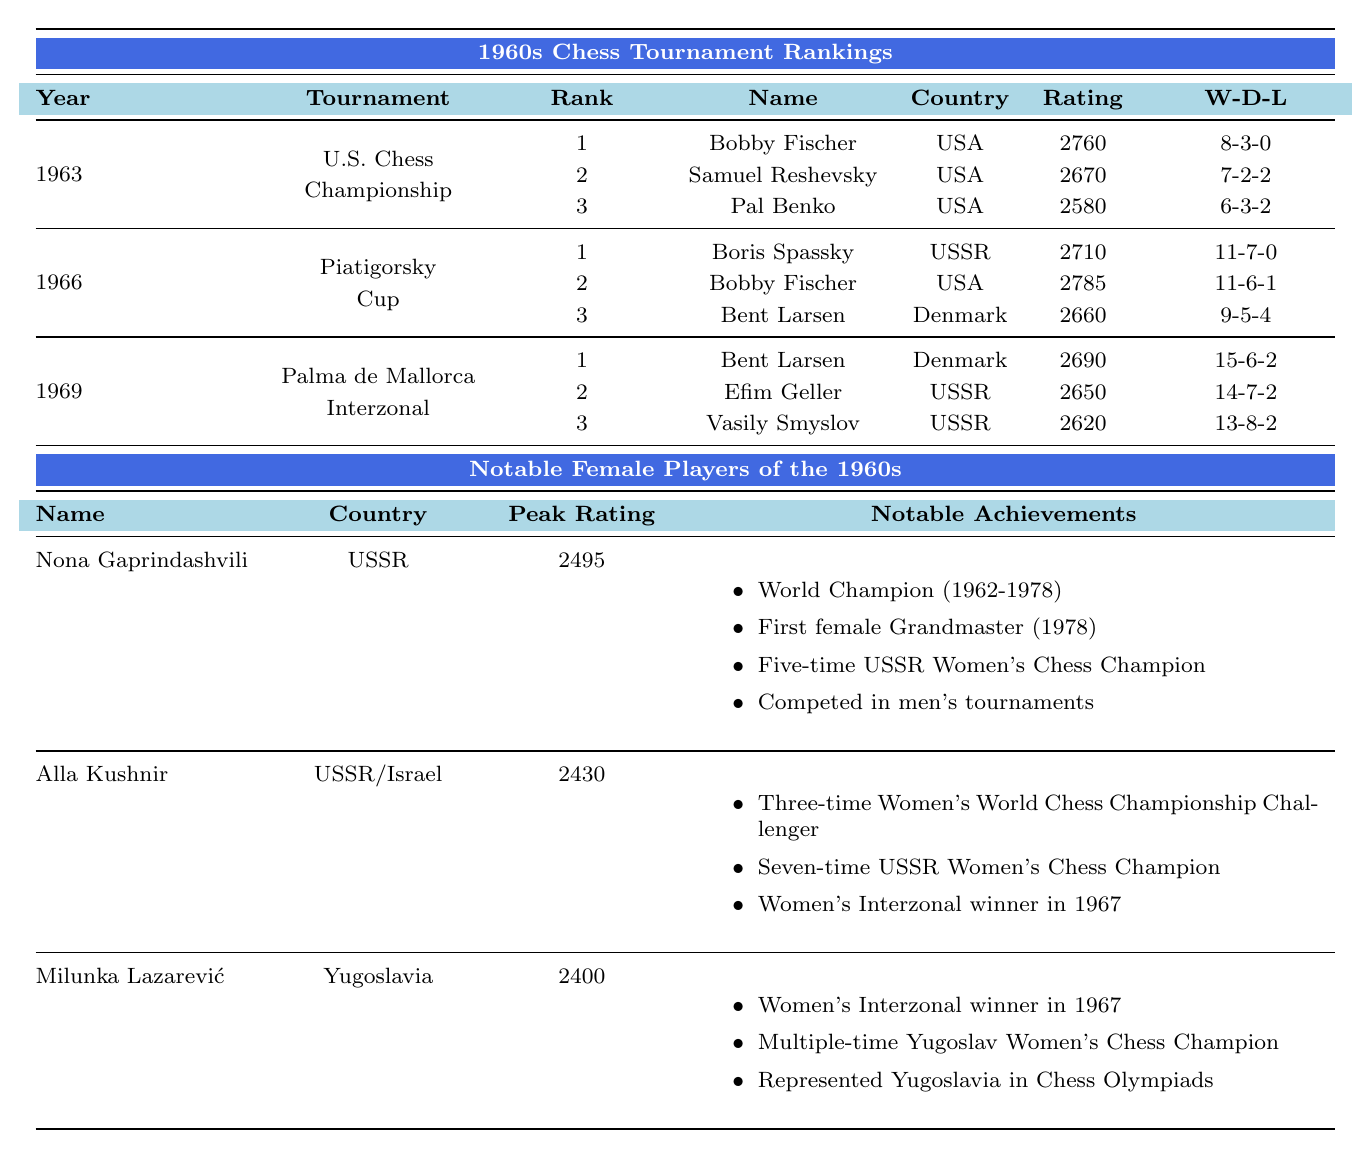What year did Bobby Fischer rank first in the U.S. Chess Championship? Bobby Fischer ranked first in the U.S. Chess Championship in the year 1963, as indicated in the table.
Answer: 1963 Which country did Boris Spassky represent in the Piatigorsky Cup? Boris Spassky represented the USSR in the Piatigorsky Cup, as shown in the tournament rankings.
Answer: USSR What was the highest rating achieved by any player in the Piatigorsky Cup? The highest rating in the Piatigorsky Cup was 2785, achieved by Bobby Fischer. This is indicated in the ratings column.
Answer: 2785 How many games did Bent Larsen play in the Palma de Mallorca Interzonal? Bent Larsen played 23 games in the Palma de Mallorca Interzonal, which is listed in the Games Played column for that tournament.
Answer: 23 Which player had the most wins in the U.S. Chess Championship of 1963? Bobby Fischer had the most wins in the U.S. Chess Championship of 1963 with 8 wins, as noted in the Wins column.
Answer: Bobby Fischer Did Nona Gaprindashvili hold the title of World Champion in the 1960s? Yes, Nona Gaprindashvili was a World Champion from 1962 to 1978, as stated in the table.
Answer: Yes What is the average rating of the top three players in the 1963 U.S. Chess Championship? The ratings of the top three players are 2760, 2670, and 2580. Summing these values gives 8010; dividing by 3 yields an average rating of 2670.
Answer: 2670 How many losses did Bobby Fischer have in the Piatigorsky Cup? Bobby Fischer had 1 loss in the Piatigorsky Cup, as indicated in the Losses column.
Answer: 1 Which player in the Palma de Mallorca Interzonal had the highest number of draws? Vasily Smyslov had the highest number of draws in the Palma de Mallorca Interzonal with 8 draws, as per the Draws column.
Answer: Vasily Smyslov What was the peak rating of Alla Kushnir? Alla Kushnir's peak rating was 2430, as shown in the table under Peak Rating.
Answer: 2430 Which player had a better win-loss ratio: Bent Larsen in 1969 or Bobby Fischer in 1966? Bent Larsen had 15 wins and 2 losses giving a ratio of 15:2, while Bobby Fischer had 11 wins and 1 loss, a ratio of 11:1. To compare, 15:2 is 7.5 and 11:1 is 11, so Bobby Fischer had a better win-loss ratio.
Answer: Bobby Fischer How many notable achievements are listed for Nona Gaprindashvili? There are four notable achievements listed for Nona Gaprindashvili in the table, as detailed under Notable Achievements.
Answer: 4 Was Bent Larsen ranked first in any tournament during the 1960s? Yes, Bent Larsen was ranked first in the Palma de Mallorca Interzonal in 1969. This is clearly mentioned in the rankings.
Answer: Yes 